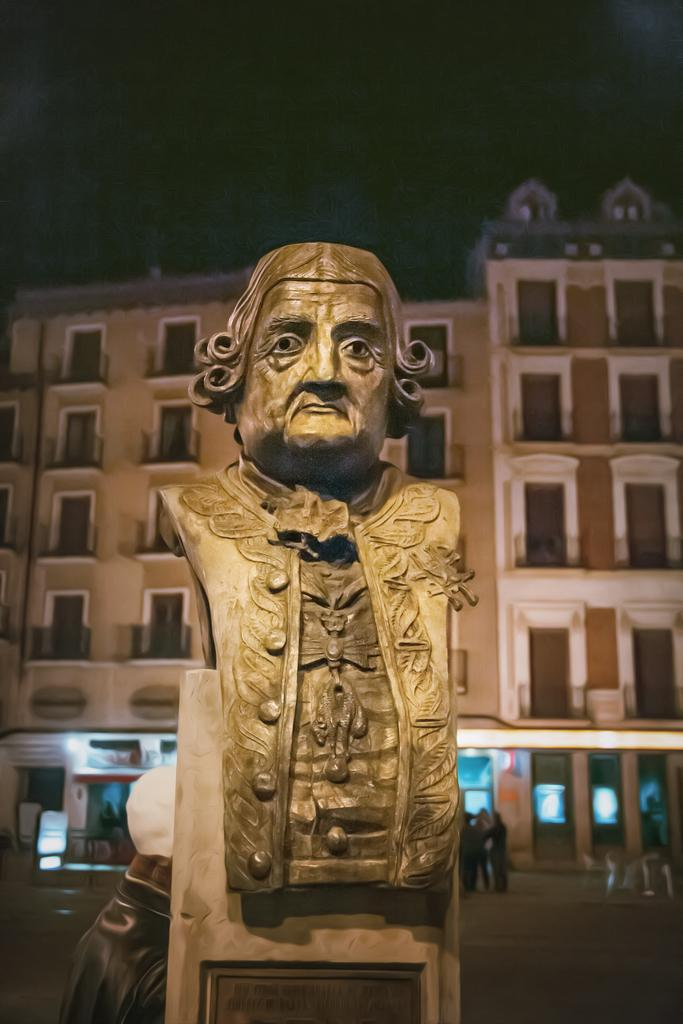What is the main subject in the image? There is a statue in the image. What can be seen in the background of the image? There are buildings behind the statue. Are there any other living beings in the image besides the statue? Yes, there are people in the image. What type of door can be seen on the statue in the image? There is no door present on the statue in the image. 